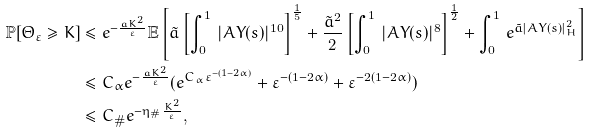Convert formula to latex. <formula><loc_0><loc_0><loc_500><loc_500>\mathbb { P } [ \Theta _ { \varepsilon } \geq K ] & \leq e ^ { - \frac { a K ^ { 2 } } { \varepsilon } } \mathbb { E } \left [ \tilde { a } \left [ \int _ { 0 } ^ { 1 } \, | A Y ( s ) | ^ { 1 0 } \right ] ^ { \frac { 1 } { 5 } } + \frac { \tilde { a } ^ { 2 } } 2 \left [ \int _ { 0 } ^ { 1 } \, | A Y ( s ) | ^ { 8 } \right ] ^ { \frac { 1 } { 2 } } + \int _ { 0 } ^ { 1 } \, e ^ { \tilde { a } | A Y ( s ) | _ { H } ^ { 2 } } \right ] \\ & \leq C _ { \alpha } e ^ { - \frac { a K ^ { 2 } } \varepsilon } ( e ^ { C _ { \alpha } \varepsilon ^ { - ( 1 - 2 \alpha ) } } + \varepsilon ^ { - ( 1 - 2 \alpha ) } + \varepsilon ^ { - 2 ( 1 - 2 \alpha ) } ) \\ & \leq C _ { \# } e ^ { - \eta _ { \# } \frac { K ^ { 2 } } { \varepsilon } } ,</formula> 